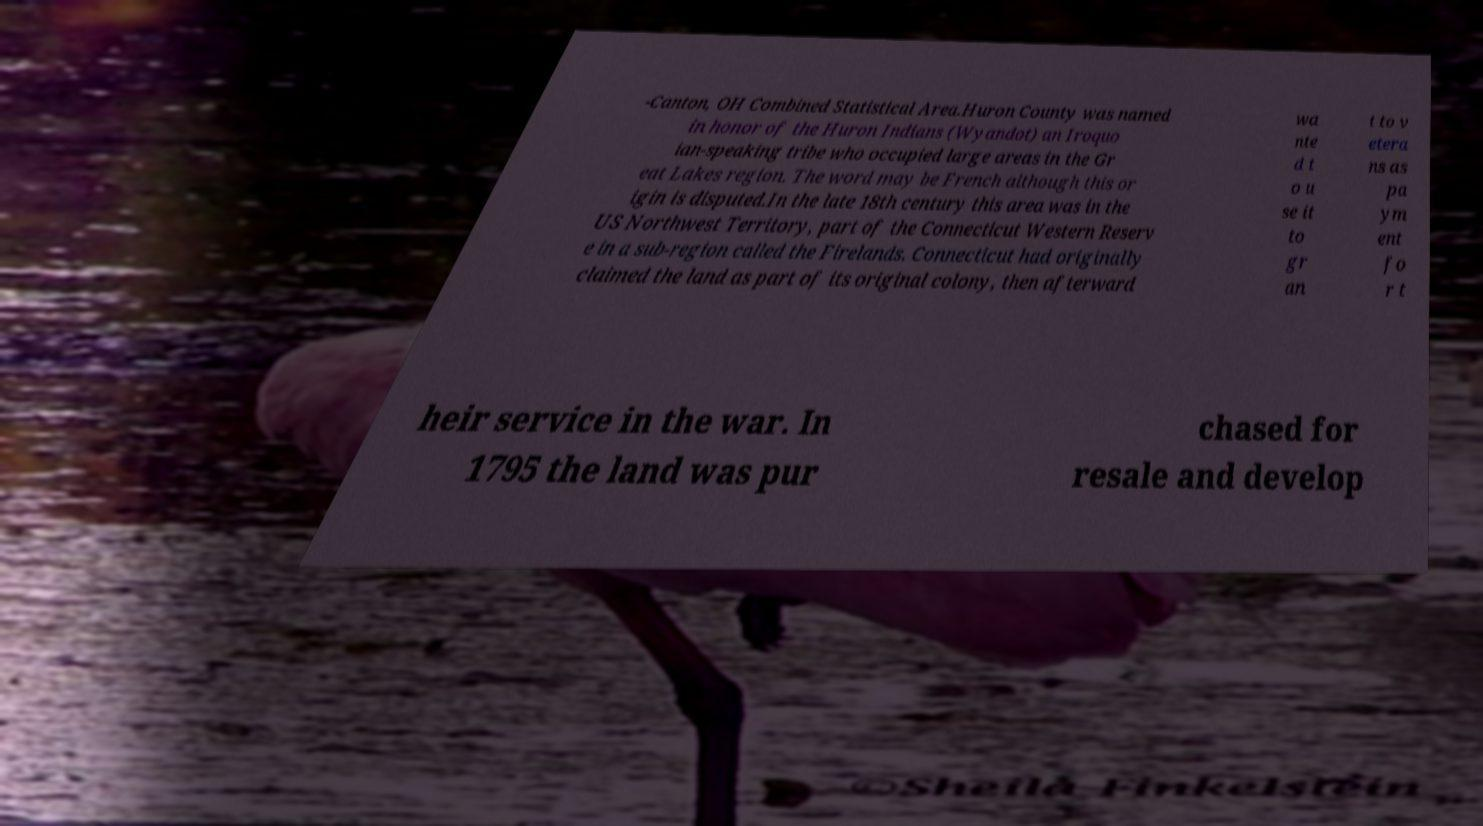Can you accurately transcribe the text from the provided image for me? -Canton, OH Combined Statistical Area.Huron County was named in honor of the Huron Indians (Wyandot) an Iroquo ian-speaking tribe who occupied large areas in the Gr eat Lakes region. The word may be French although this or igin is disputed.In the late 18th century this area was in the US Northwest Territory, part of the Connecticut Western Reserv e in a sub-region called the Firelands. Connecticut had originally claimed the land as part of its original colony, then afterward wa nte d t o u se it to gr an t to v etera ns as pa ym ent fo r t heir service in the war. In 1795 the land was pur chased for resale and develop 